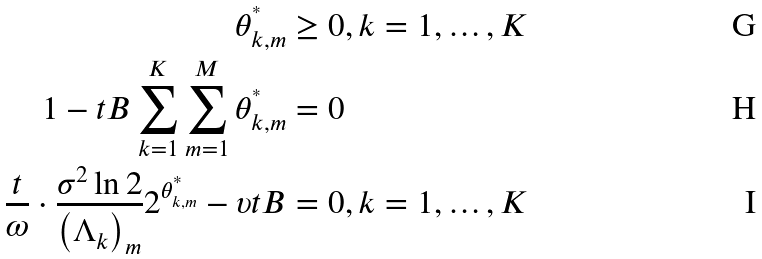Convert formula to latex. <formula><loc_0><loc_0><loc_500><loc_500>\theta _ { k , m } ^ { ^ { * } } & \geq 0 , k = 1 , \dots , K \\ 1 - t B \sum _ { k = 1 } ^ { K } \sum _ { m = 1 } ^ { M } \theta _ { k , m } ^ { ^ { * } } & = 0 \\ \frac { t } { \omega } \cdot \frac { \sigma ^ { 2 } \ln 2 } { \left ( \Lambda _ { k } \right ) _ { m } } 2 ^ { \theta _ { k , m } ^ { ^ { * } } } - \upsilon t B & = 0 , k = 1 , \dots , K</formula> 